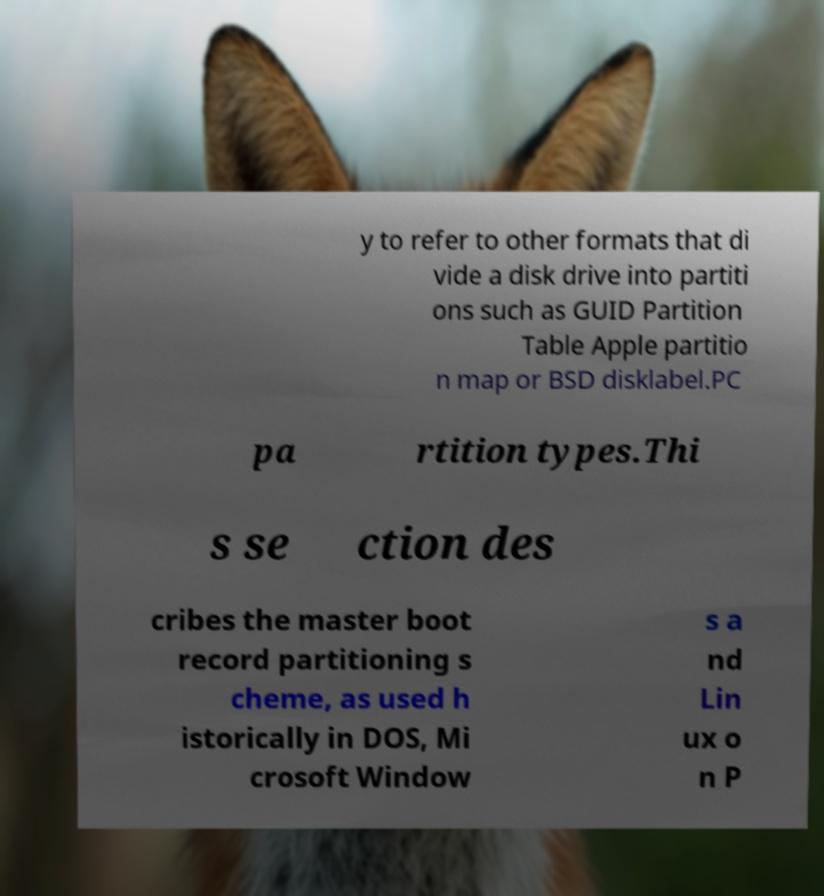Could you extract and type out the text from this image? y to refer to other formats that di vide a disk drive into partiti ons such as GUID Partition Table Apple partitio n map or BSD disklabel.PC pa rtition types.Thi s se ction des cribes the master boot record partitioning s cheme, as used h istorically in DOS, Mi crosoft Window s a nd Lin ux o n P 